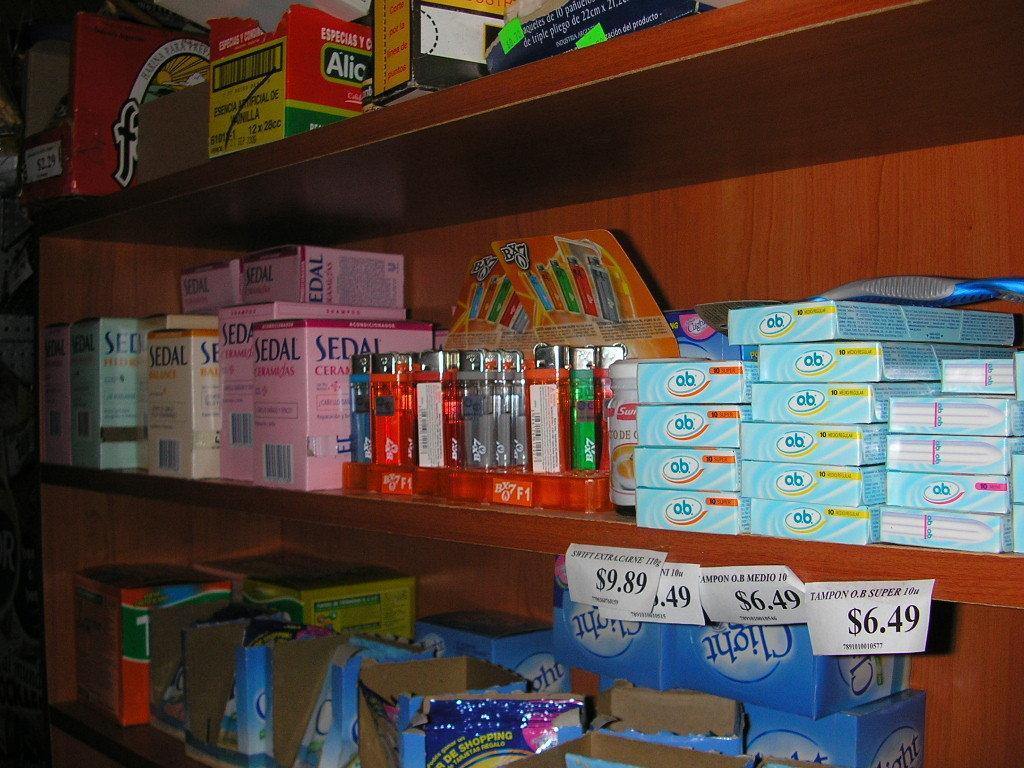Are there items that cost more than $6.49?
Give a very brief answer. Yes. Can you buy sedal here?
Keep it short and to the point. Yes. 